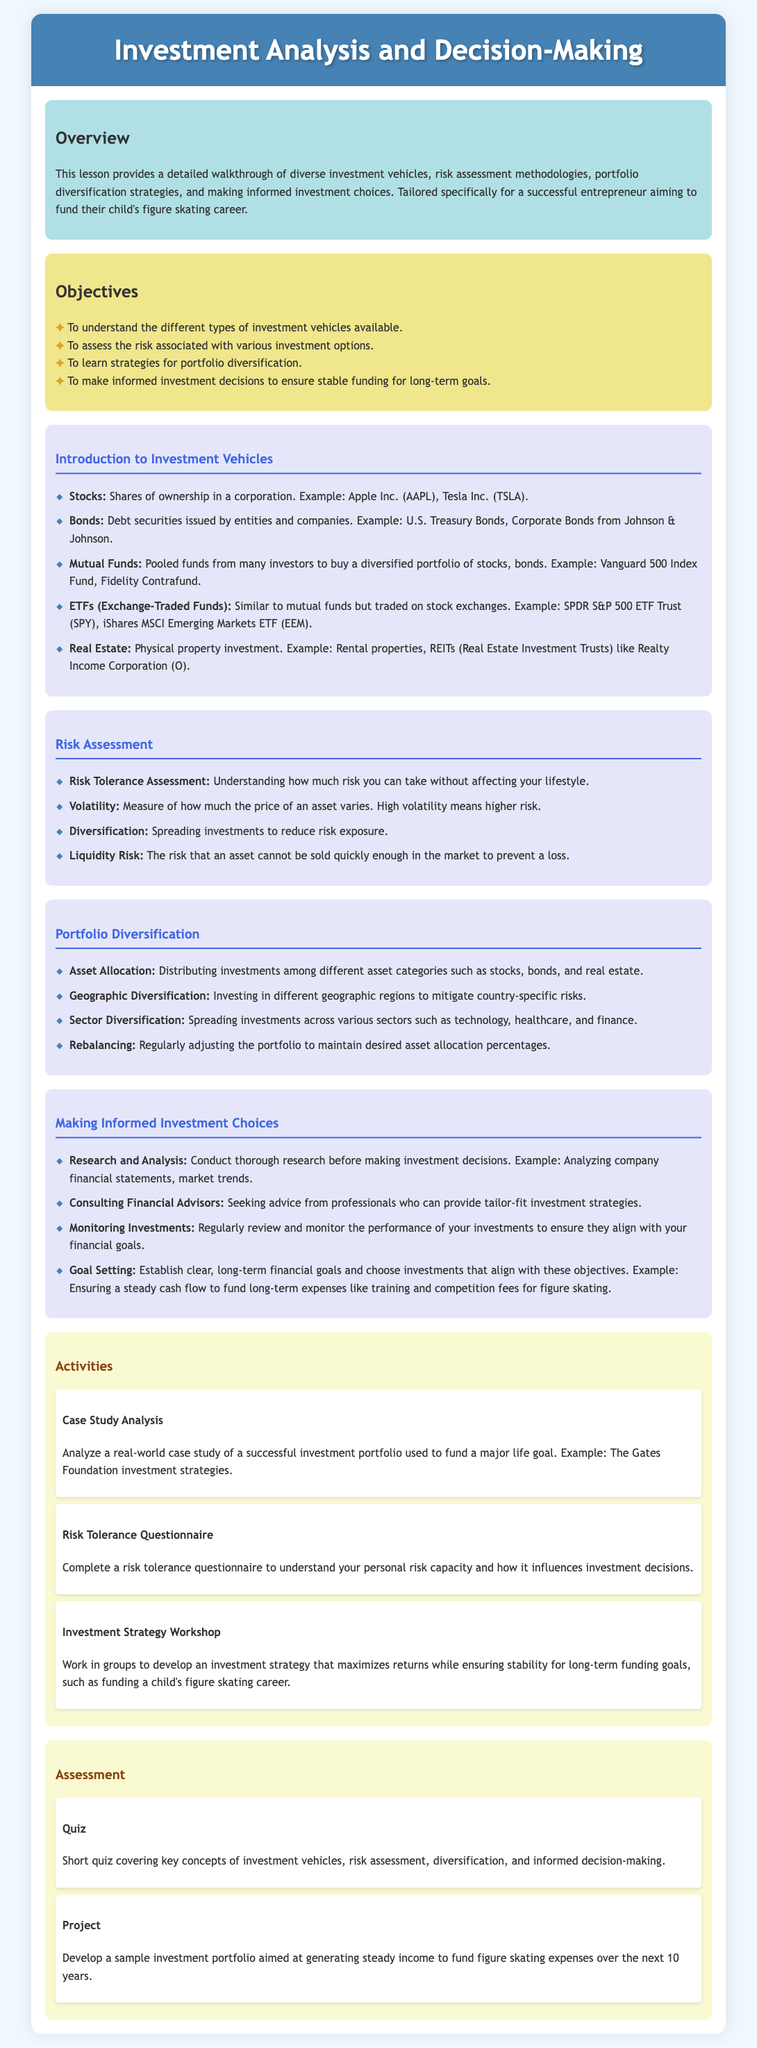What are the investment vehicles covered? The document lists various investment vehicles, including Stocks, Bonds, Mutual Funds, ETFs, and Real Estate.
Answer: Stocks, Bonds, Mutual Funds, ETFs, Real Estate What is the objective related to risk assessment? One of the objectives is to assess the risk associated with various investment options.
Answer: Assess the risk associated with various investment options What is an example of a Mutual Fund mentioned? The document provides examples of investment vehicles, such as the Vanguard 500 Index Fund for Mutual Funds.
Answer: Vanguard 500 Index Fund What type of risk does liquidity risk refer to? Liquidity risk is described as the risk that an asset cannot be sold quickly enough in the market to prevent a loss.
Answer: Cannot be sold quickly enough How often should a portfolio be rebalanced? The lesson implies the importance of regularly adjusting the portfolio, though it does not specify a particular frequency; hence, it can be interpreted generally.
Answer: Regularly What is one activity suggested in the lesson? The lesson plan includes an activity called "Investment Strategy Workshop".
Answer: Investment Strategy Workshop What is the total number of objectives listed? The document indicates four specific objectives for the lesson.
Answer: Four What pricing aspect is assessed in the risk section? The volatility of an asset is discussed in the context of assessing risk.
Answer: Volatility Which assessment method involves a project? The assessment method that involves developing a sample investment portfolio is categorized as "Project".
Answer: Project 